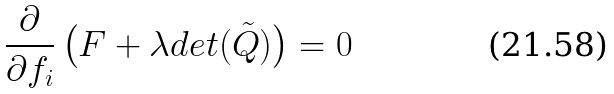Convert formula to latex. <formula><loc_0><loc_0><loc_500><loc_500>\frac { \partial } { \partial f _ { i } } \left ( F + \lambda d e t ( \tilde { Q } ) \right ) = 0</formula> 